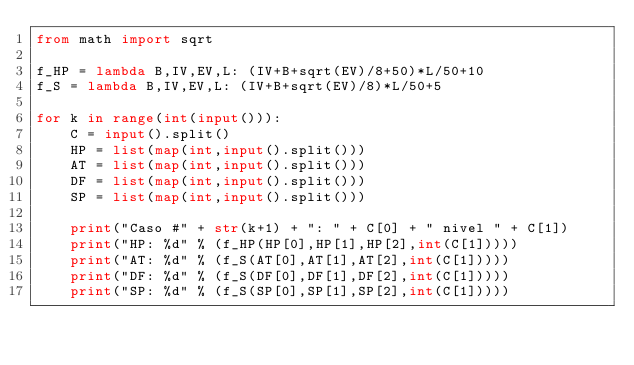Convert code to text. <code><loc_0><loc_0><loc_500><loc_500><_Python_>from math import sqrt

f_HP = lambda B,IV,EV,L: (IV+B+sqrt(EV)/8+50)*L/50+10
f_S = lambda B,IV,EV,L: (IV+B+sqrt(EV)/8)*L/50+5

for k in range(int(input())):
    C = input().split()
    HP = list(map(int,input().split()))
    AT = list(map(int,input().split()))
    DF = list(map(int,input().split()))
    SP = list(map(int,input().split()))

    print("Caso #" + str(k+1) + ": " + C[0] + " nivel " + C[1])
    print("HP: %d" % (f_HP(HP[0],HP[1],HP[2],int(C[1]))))
    print("AT: %d" % (f_S(AT[0],AT[1],AT[2],int(C[1]))))
    print("DF: %d" % (f_S(DF[0],DF[1],DF[2],int(C[1]))))
    print("SP: %d" % (f_S(SP[0],SP[1],SP[2],int(C[1]))))
</code> 